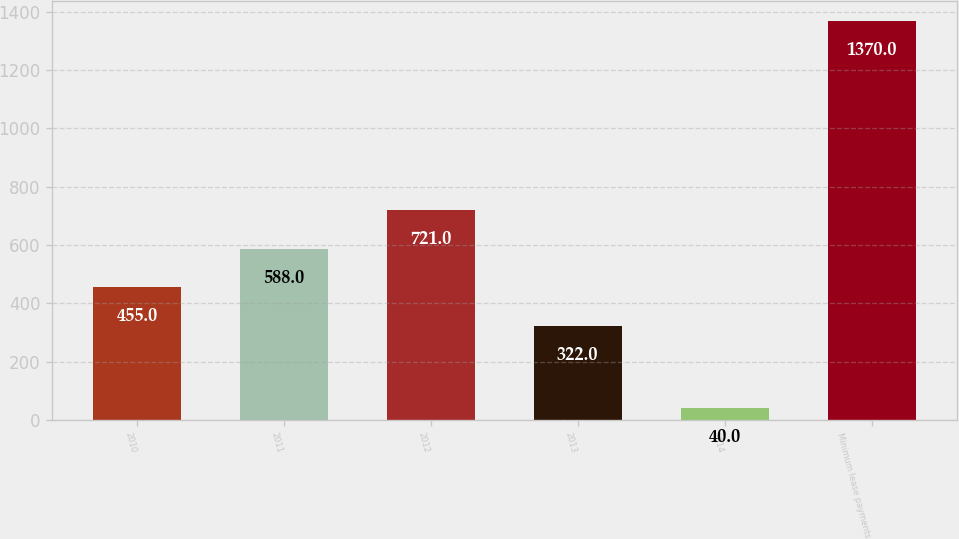Convert chart. <chart><loc_0><loc_0><loc_500><loc_500><bar_chart><fcel>2010<fcel>2011<fcel>2012<fcel>2013<fcel>2014<fcel>Minimum lease payments<nl><fcel>455<fcel>588<fcel>721<fcel>322<fcel>40<fcel>1370<nl></chart> 